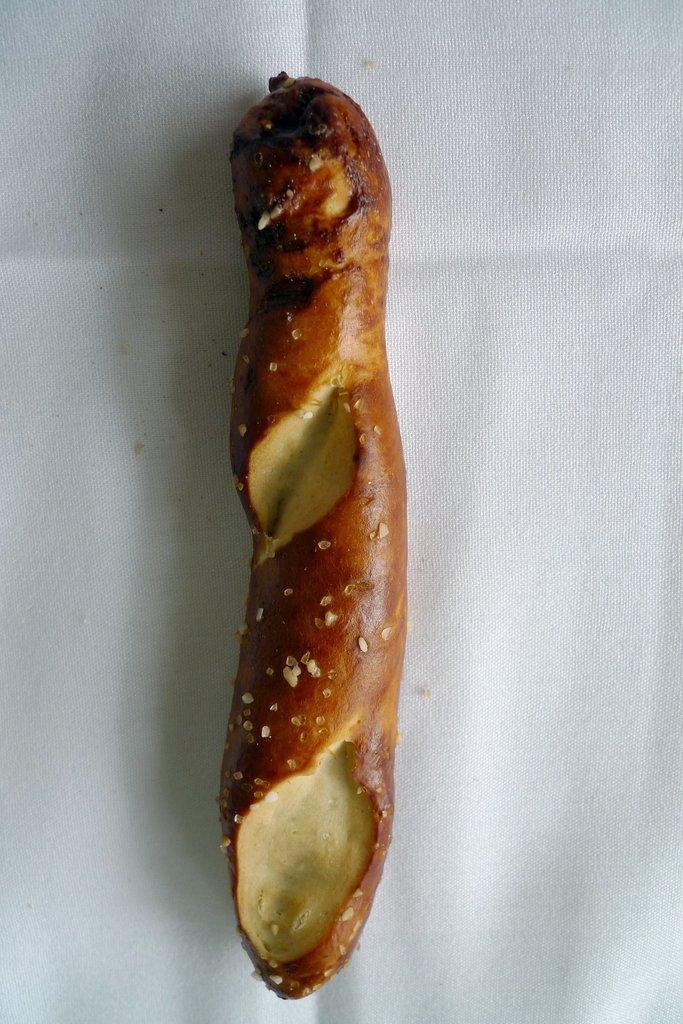Please provide a concise description of this image. In this picture I can see food and a white color background. 